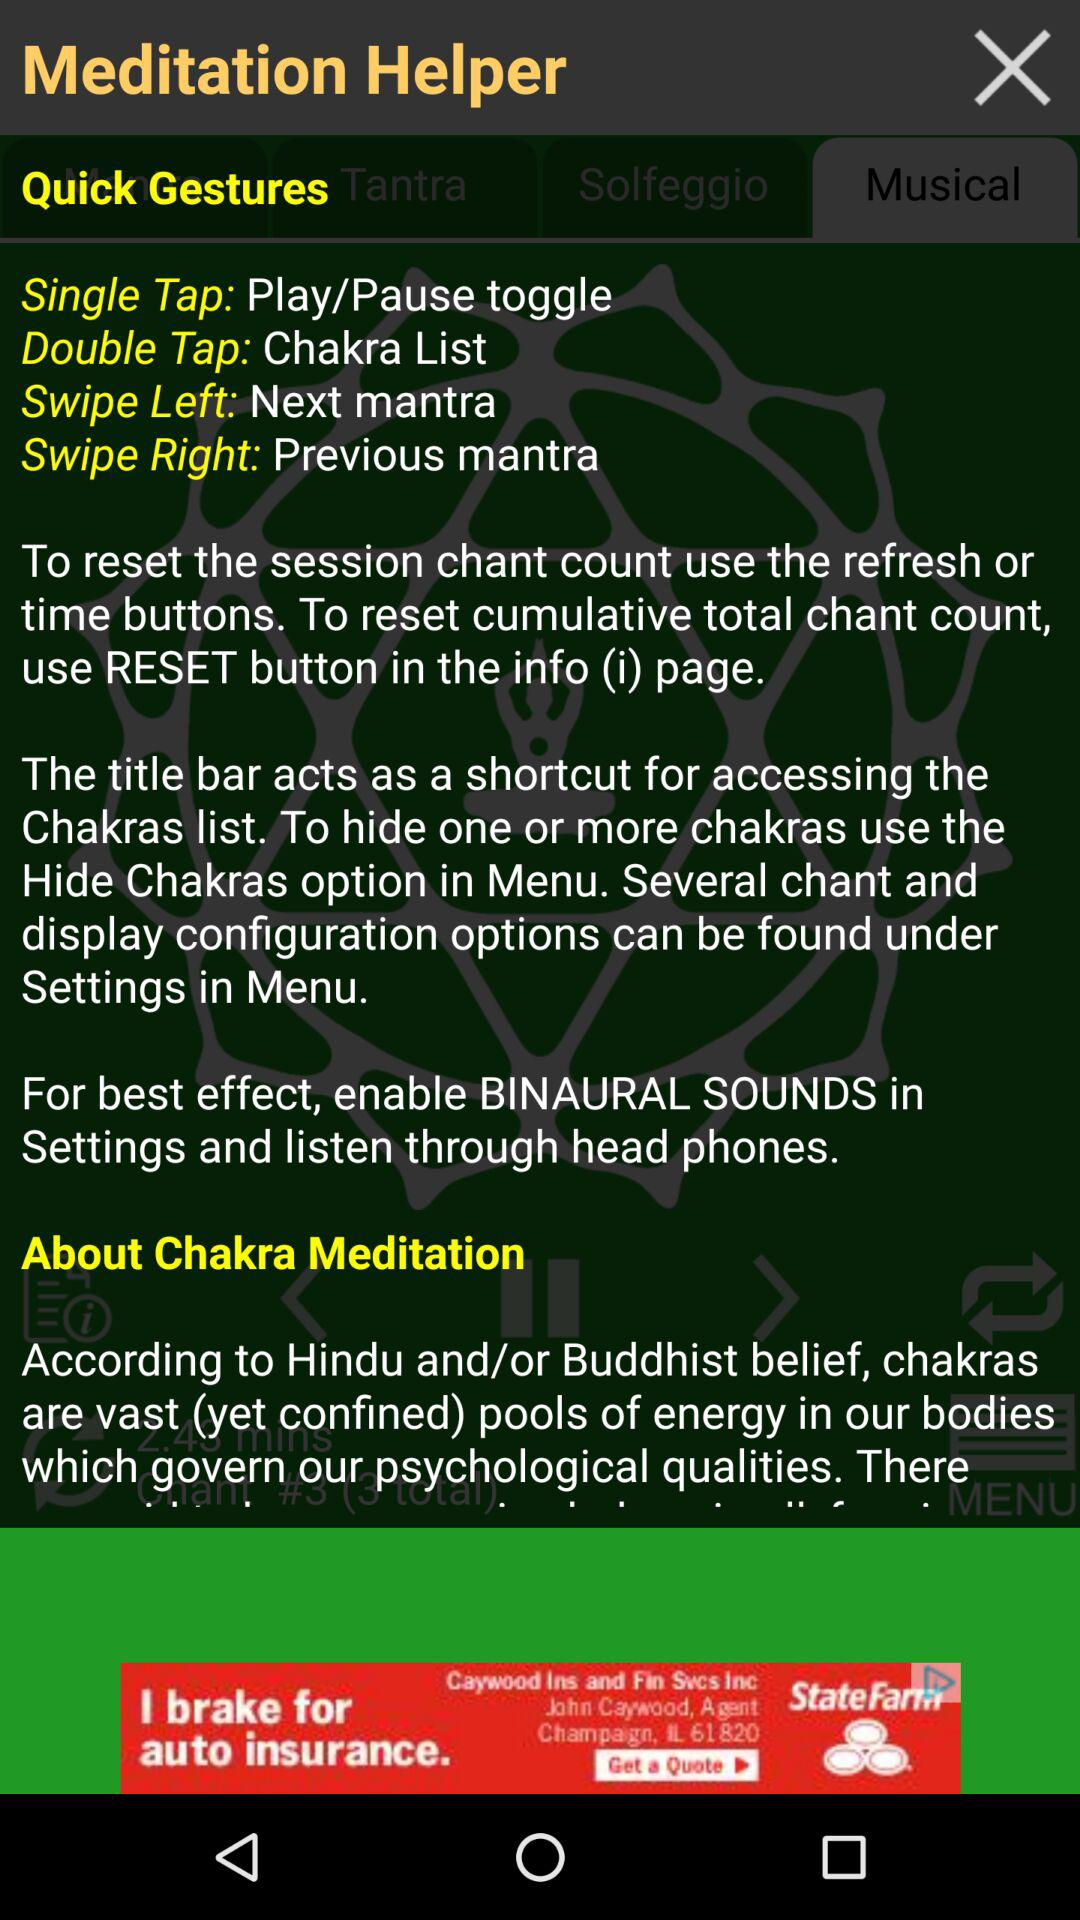Which side do I have to swipe for the next mantra? You have to swipe left for the next mantra. 